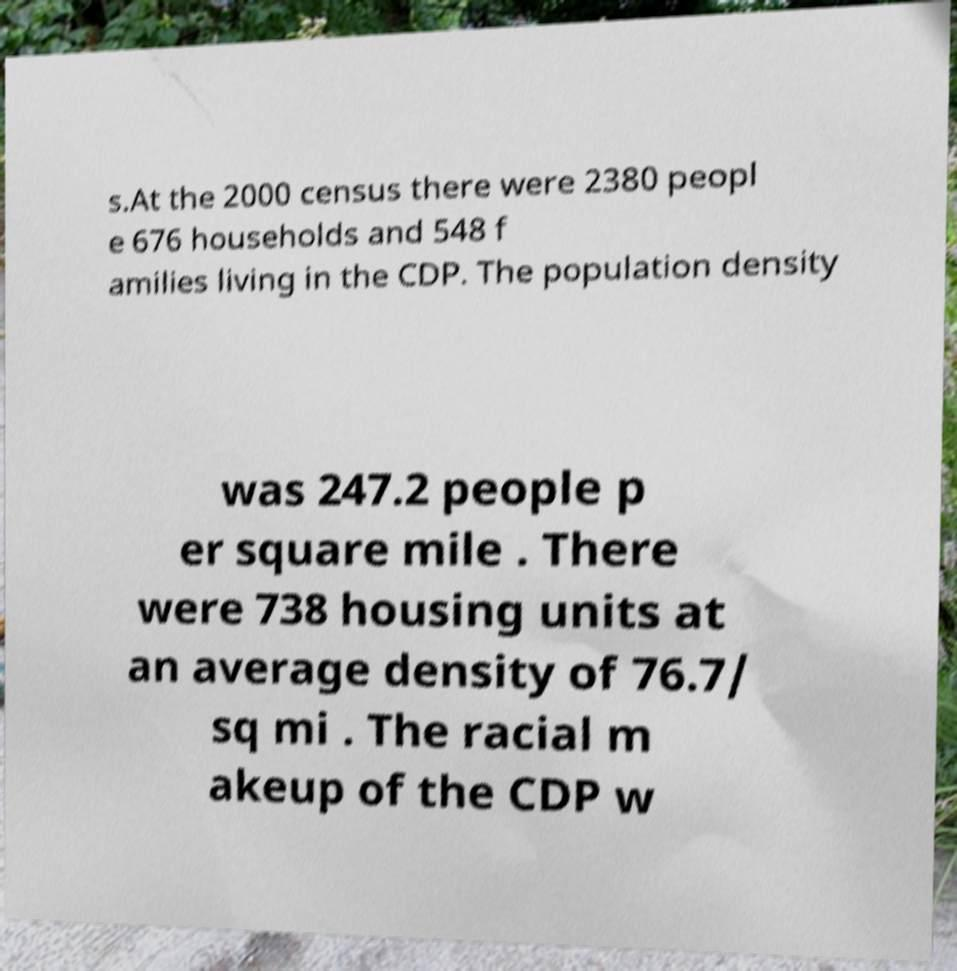Please read and relay the text visible in this image. What does it say? s.At the 2000 census there were 2380 peopl e 676 households and 548 f amilies living in the CDP. The population density was 247.2 people p er square mile . There were 738 housing units at an average density of 76.7/ sq mi . The racial m akeup of the CDP w 